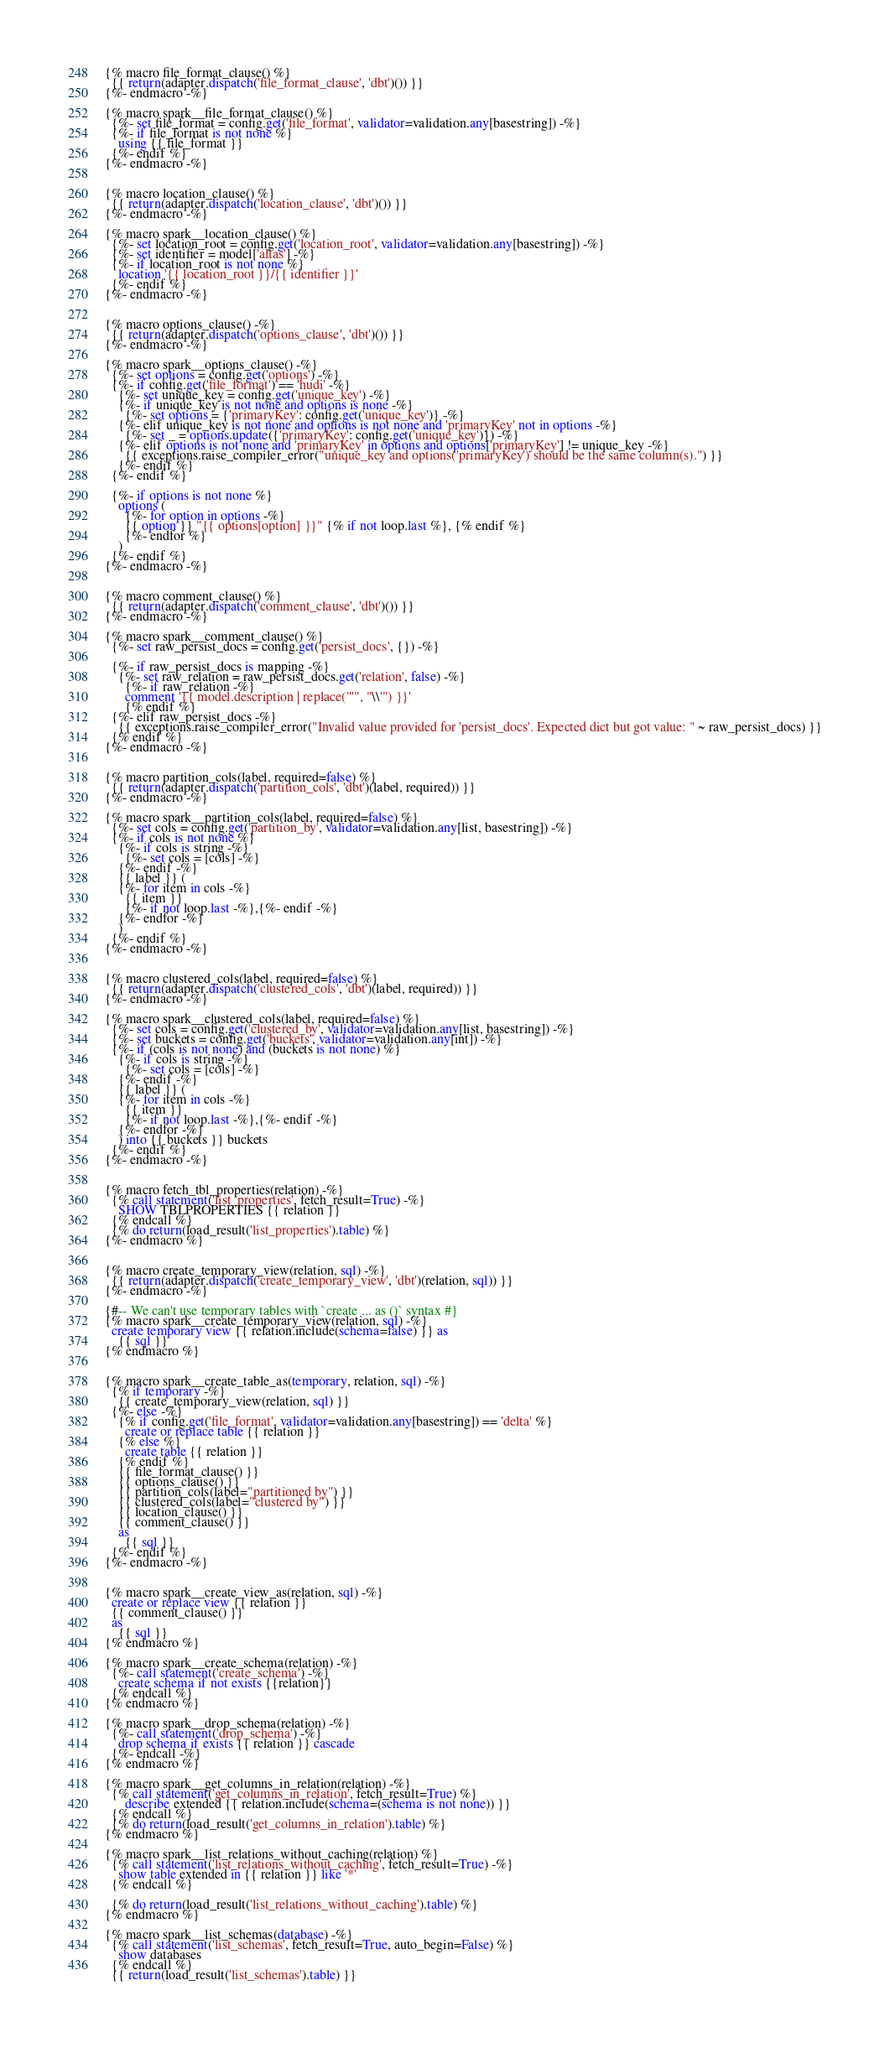Convert code to text. <code><loc_0><loc_0><loc_500><loc_500><_SQL_>{% macro file_format_clause() %}
  {{ return(adapter.dispatch('file_format_clause', 'dbt')()) }}
{%- endmacro -%}

{% macro spark__file_format_clause() %}
  {%- set file_format = config.get('file_format', validator=validation.any[basestring]) -%}
  {%- if file_format is not none %}
    using {{ file_format }}
  {%- endif %}
{%- endmacro -%}


{% macro location_clause() %}
  {{ return(adapter.dispatch('location_clause', 'dbt')()) }}
{%- endmacro -%}

{% macro spark__location_clause() %}
  {%- set location_root = config.get('location_root', validator=validation.any[basestring]) -%}
  {%- set identifier = model['alias'] -%}
  {%- if location_root is not none %}
    location '{{ location_root }}/{{ identifier }}'
  {%- endif %}
{%- endmacro -%}


{% macro options_clause() -%}
  {{ return(adapter.dispatch('options_clause', 'dbt')()) }}
{%- endmacro -%}

{% macro spark__options_clause() -%}
  {%- set options = config.get('options') -%}
  {%- if config.get('file_format') == 'hudi' -%}
    {%- set unique_key = config.get('unique_key') -%}
    {%- if unique_key is not none and options is none -%}
      {%- set options = {'primaryKey': config.get('unique_key')} -%}
    {%- elif unique_key is not none and options is not none and 'primaryKey' not in options -%}
      {%- set _ = options.update({'primaryKey': config.get('unique_key')}) -%}
    {%- elif options is not none and 'primaryKey' in options and options['primaryKey'] != unique_key -%}
      {{ exceptions.raise_compiler_error("unique_key and options('primaryKey') should be the same column(s).") }}
    {%- endif %}
  {%- endif %}

  {%- if options is not none %}
    options (
      {%- for option in options -%}
      {{ option }} "{{ options[option] }}" {% if not loop.last %}, {% endif %}
      {%- endfor %}
    )
  {%- endif %}
{%- endmacro -%}


{% macro comment_clause() %}
  {{ return(adapter.dispatch('comment_clause', 'dbt')()) }}
{%- endmacro -%}

{% macro spark__comment_clause() %}
  {%- set raw_persist_docs = config.get('persist_docs', {}) -%}

  {%- if raw_persist_docs is mapping -%}
    {%- set raw_relation = raw_persist_docs.get('relation', false) -%}
      {%- if raw_relation -%}
      comment '{{ model.description | replace("'", "\\'") }}'
      {% endif %}
  {%- elif raw_persist_docs -%}
    {{ exceptions.raise_compiler_error("Invalid value provided for 'persist_docs'. Expected dict but got value: " ~ raw_persist_docs) }}
  {% endif %}
{%- endmacro -%}


{% macro partition_cols(label, required=false) %}
  {{ return(adapter.dispatch('partition_cols', 'dbt')(label, required)) }}
{%- endmacro -%}

{% macro spark__partition_cols(label, required=false) %}
  {%- set cols = config.get('partition_by', validator=validation.any[list, basestring]) -%}
  {%- if cols is not none %}
    {%- if cols is string -%}
      {%- set cols = [cols] -%}
    {%- endif -%}
    {{ label }} (
    {%- for item in cols -%}
      {{ item }}
      {%- if not loop.last -%},{%- endif -%}
    {%- endfor -%}
    )
  {%- endif %}
{%- endmacro -%}


{% macro clustered_cols(label, required=false) %}
  {{ return(adapter.dispatch('clustered_cols', 'dbt')(label, required)) }}
{%- endmacro -%}

{% macro spark__clustered_cols(label, required=false) %}
  {%- set cols = config.get('clustered_by', validator=validation.any[list, basestring]) -%}
  {%- set buckets = config.get('buckets', validator=validation.any[int]) -%}
  {%- if (cols is not none) and (buckets is not none) %}
    {%- if cols is string -%}
      {%- set cols = [cols] -%}
    {%- endif -%}
    {{ label }} (
    {%- for item in cols -%}
      {{ item }}
      {%- if not loop.last -%},{%- endif -%}
    {%- endfor -%}
    ) into {{ buckets }} buckets
  {%- endif %}
{%- endmacro -%}


{% macro fetch_tbl_properties(relation) -%}
  {% call statement('list_properties', fetch_result=True) -%}
    SHOW TBLPROPERTIES {{ relation }}
  {% endcall %}
  {% do return(load_result('list_properties').table) %}
{%- endmacro %}


{% macro create_temporary_view(relation, sql) -%}
  {{ return(adapter.dispatch('create_temporary_view', 'dbt')(relation, sql)) }}
{%- endmacro -%}

{#-- We can't use temporary tables with `create ... as ()` syntax #}
{% macro spark__create_temporary_view(relation, sql) -%}
  create temporary view {{ relation.include(schema=false) }} as
    {{ sql }}
{% endmacro %}


{% macro spark__create_table_as(temporary, relation, sql) -%}
  {% if temporary -%}
    {{ create_temporary_view(relation, sql) }}
  {%- else -%}
    {% if config.get('file_format', validator=validation.any[basestring]) == 'delta' %}
      create or replace table {{ relation }}
    {% else %}
      create table {{ relation }}
    {% endif %}
    {{ file_format_clause() }}
    {{ options_clause() }}
    {{ partition_cols(label="partitioned by") }}
    {{ clustered_cols(label="clustered by") }}
    {{ location_clause() }}
    {{ comment_clause() }}
    as
      {{ sql }}
  {%- endif %}
{%- endmacro -%}


{% macro spark__create_view_as(relation, sql) -%}
  create or replace view {{ relation }}
  {{ comment_clause() }}
  as
    {{ sql }}
{% endmacro %}

{% macro spark__create_schema(relation) -%}
  {%- call statement('create_schema') -%}
    create schema if not exists {{relation}}
  {% endcall %}
{% endmacro %}

{% macro spark__drop_schema(relation) -%}
  {%- call statement('drop_schema') -%}
    drop schema if exists {{ relation }} cascade
  {%- endcall -%}
{% endmacro %}

{% macro spark__get_columns_in_relation(relation) -%}
  {% call statement('get_columns_in_relation', fetch_result=True) %}
      describe extended {{ relation.include(schema=(schema is not none)) }}
  {% endcall %}
  {% do return(load_result('get_columns_in_relation').table) %}
{% endmacro %}

{% macro spark__list_relations_without_caching(relation) %}
  {% call statement('list_relations_without_caching', fetch_result=True) -%}
    show table extended in {{ relation }} like '*'
  {% endcall %}

  {% do return(load_result('list_relations_without_caching').table) %}
{% endmacro %}

{% macro spark__list_schemas(database) -%}
  {% call statement('list_schemas', fetch_result=True, auto_begin=False) %}
    show databases
  {% endcall %}
  {{ return(load_result('list_schemas').table) }}</code> 